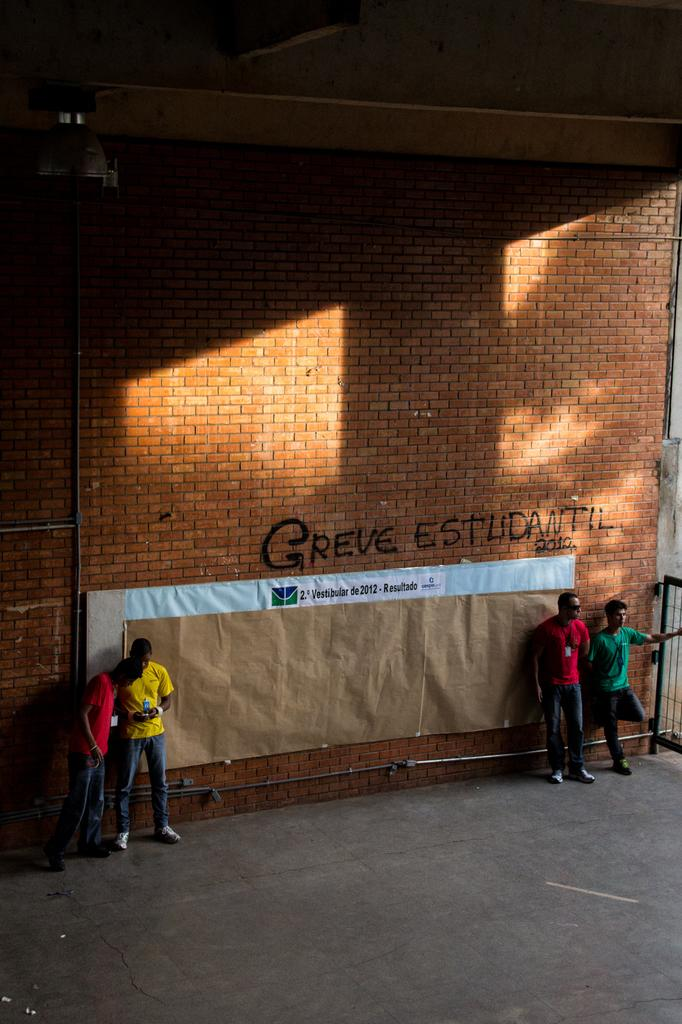Who or what can be seen in the image? There are people in the image. What is written or depicted on the brick wall? There is a brick wall with text in the image. What else is present on the wall or nearby? There are posters in the image. What can be seen on the right side of the image? There is an object on the right side of the image. What type of surface is visible in the image? The ground is visible in the image. What type of music is being played by the band in the image? A: There is no band present in the image, so it is not possible to determine what type of music might be played. 